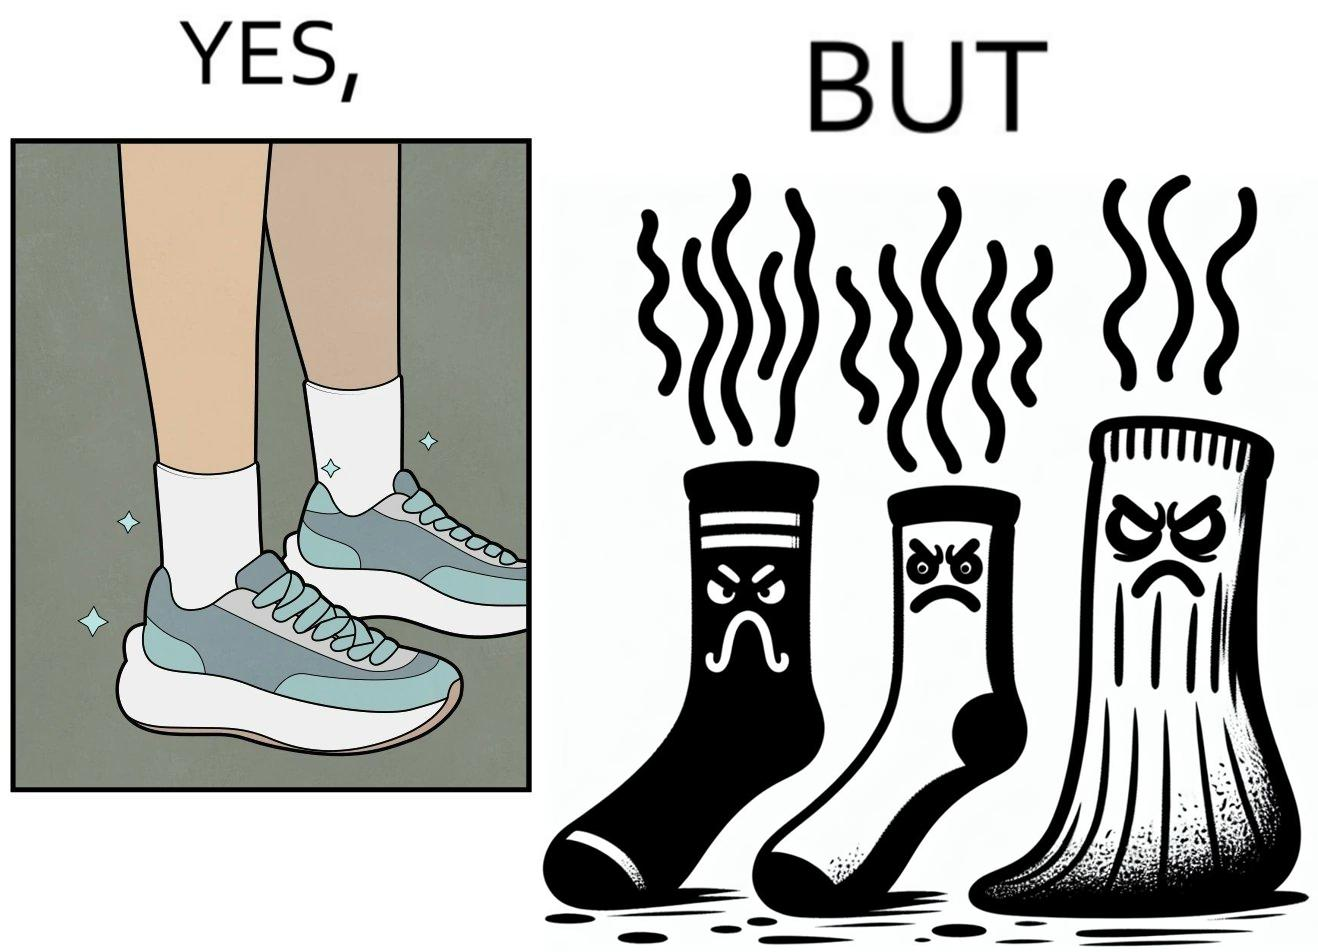What is shown in this image? The person's shocks is very dirty although the shoes are very clean. Thus there is an irony that not all things are same as they appear. 